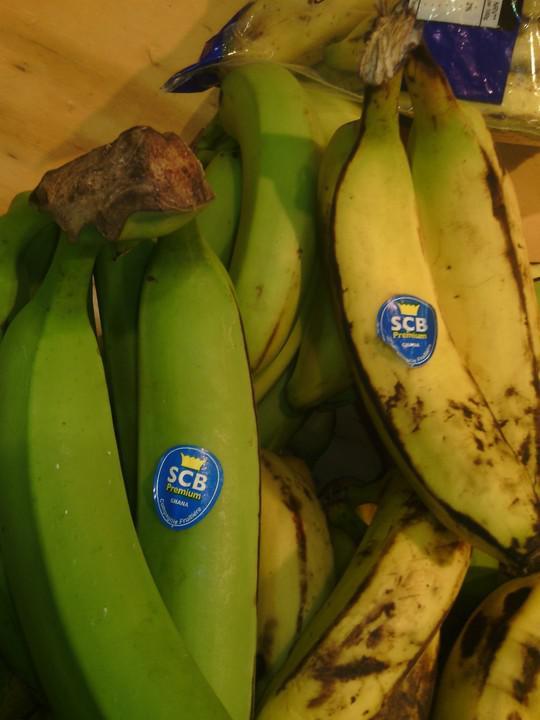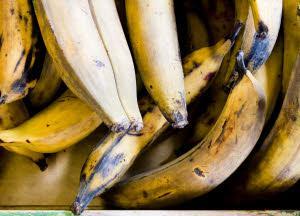The first image is the image on the left, the second image is the image on the right. For the images shown, is this caption "The right image shows only overripe, brownish-yellow bananas with their peels intact, and the left image includes bananas and at least one other type of fruit." true? Answer yes or no. No. The first image is the image on the left, the second image is the image on the right. Analyze the images presented: Is the assertion "In the left image bananas are displayed with at least one other type of fruit." valid? Answer yes or no. No. 